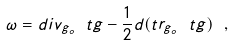Convert formula to latex. <formula><loc_0><loc_0><loc_500><loc_500>\omega = d i v _ { g _ { o } } \ t g - \frac { 1 } { 2 } d ( t r _ { g _ { o } } \ t g ) \ ,</formula> 